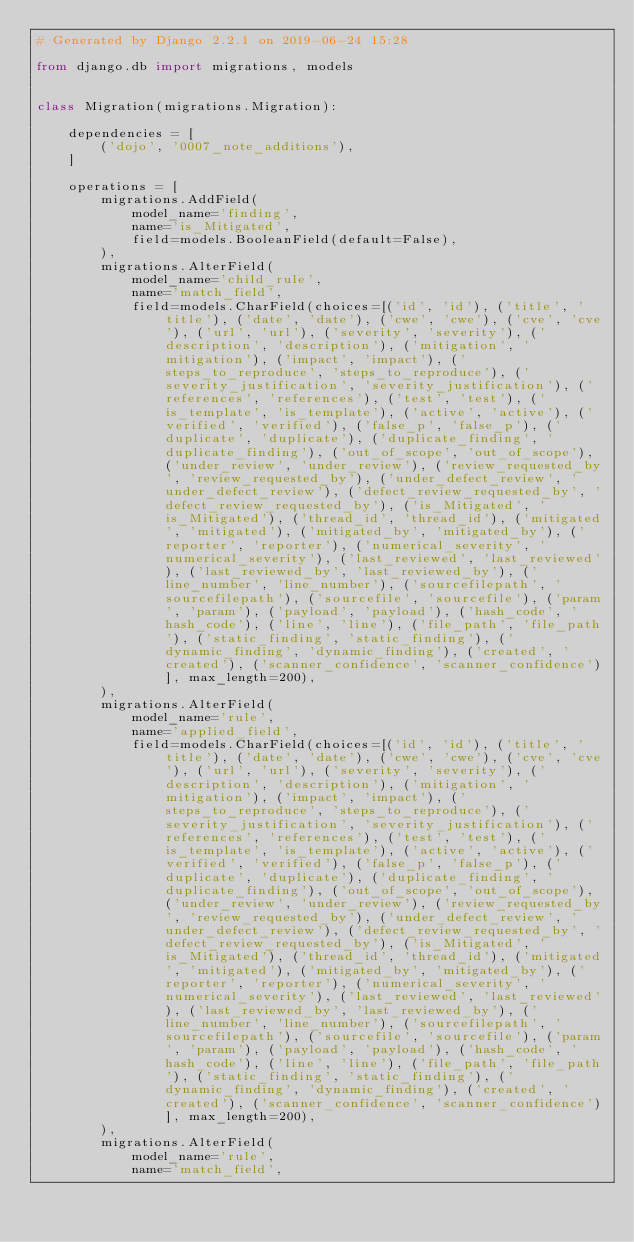<code> <loc_0><loc_0><loc_500><loc_500><_Python_># Generated by Django 2.2.1 on 2019-06-24 15:28

from django.db import migrations, models


class Migration(migrations.Migration):

    dependencies = [
        ('dojo', '0007_note_additions'),
    ]

    operations = [
        migrations.AddField(
            model_name='finding',
            name='is_Mitigated',
            field=models.BooleanField(default=False),
        ),
        migrations.AlterField(
            model_name='child_rule',
            name='match_field',
            field=models.CharField(choices=[('id', 'id'), ('title', 'title'), ('date', 'date'), ('cwe', 'cwe'), ('cve', 'cve'), ('url', 'url'), ('severity', 'severity'), ('description', 'description'), ('mitigation', 'mitigation'), ('impact', 'impact'), ('steps_to_reproduce', 'steps_to_reproduce'), ('severity_justification', 'severity_justification'), ('references', 'references'), ('test', 'test'), ('is_template', 'is_template'), ('active', 'active'), ('verified', 'verified'), ('false_p', 'false_p'), ('duplicate', 'duplicate'), ('duplicate_finding', 'duplicate_finding'), ('out_of_scope', 'out_of_scope'), ('under_review', 'under_review'), ('review_requested_by', 'review_requested_by'), ('under_defect_review', 'under_defect_review'), ('defect_review_requested_by', 'defect_review_requested_by'), ('is_Mitigated', 'is_Mitigated'), ('thread_id', 'thread_id'), ('mitigated', 'mitigated'), ('mitigated_by', 'mitigated_by'), ('reporter', 'reporter'), ('numerical_severity', 'numerical_severity'), ('last_reviewed', 'last_reviewed'), ('last_reviewed_by', 'last_reviewed_by'), ('line_number', 'line_number'), ('sourcefilepath', 'sourcefilepath'), ('sourcefile', 'sourcefile'), ('param', 'param'), ('payload', 'payload'), ('hash_code', 'hash_code'), ('line', 'line'), ('file_path', 'file_path'), ('static_finding', 'static_finding'), ('dynamic_finding', 'dynamic_finding'), ('created', 'created'), ('scanner_confidence', 'scanner_confidence')], max_length=200),
        ),
        migrations.AlterField(
            model_name='rule',
            name='applied_field',
            field=models.CharField(choices=[('id', 'id'), ('title', 'title'), ('date', 'date'), ('cwe', 'cwe'), ('cve', 'cve'), ('url', 'url'), ('severity', 'severity'), ('description', 'description'), ('mitigation', 'mitigation'), ('impact', 'impact'), ('steps_to_reproduce', 'steps_to_reproduce'), ('severity_justification', 'severity_justification'), ('references', 'references'), ('test', 'test'), ('is_template', 'is_template'), ('active', 'active'), ('verified', 'verified'), ('false_p', 'false_p'), ('duplicate', 'duplicate'), ('duplicate_finding', 'duplicate_finding'), ('out_of_scope', 'out_of_scope'), ('under_review', 'under_review'), ('review_requested_by', 'review_requested_by'), ('under_defect_review', 'under_defect_review'), ('defect_review_requested_by', 'defect_review_requested_by'), ('is_Mitigated', 'is_Mitigated'), ('thread_id', 'thread_id'), ('mitigated', 'mitigated'), ('mitigated_by', 'mitigated_by'), ('reporter', 'reporter'), ('numerical_severity', 'numerical_severity'), ('last_reviewed', 'last_reviewed'), ('last_reviewed_by', 'last_reviewed_by'), ('line_number', 'line_number'), ('sourcefilepath', 'sourcefilepath'), ('sourcefile', 'sourcefile'), ('param', 'param'), ('payload', 'payload'), ('hash_code', 'hash_code'), ('line', 'line'), ('file_path', 'file_path'), ('static_finding', 'static_finding'), ('dynamic_finding', 'dynamic_finding'), ('created', 'created'), ('scanner_confidence', 'scanner_confidence')], max_length=200),
        ),
        migrations.AlterField(
            model_name='rule',
            name='match_field',</code> 